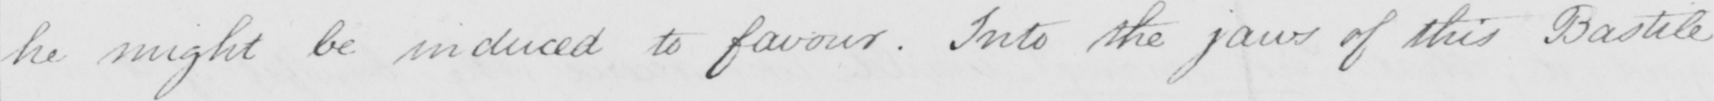Transcribe the text shown in this historical manuscript line. he might be induced to favour . Into the jaws of this Bastile 